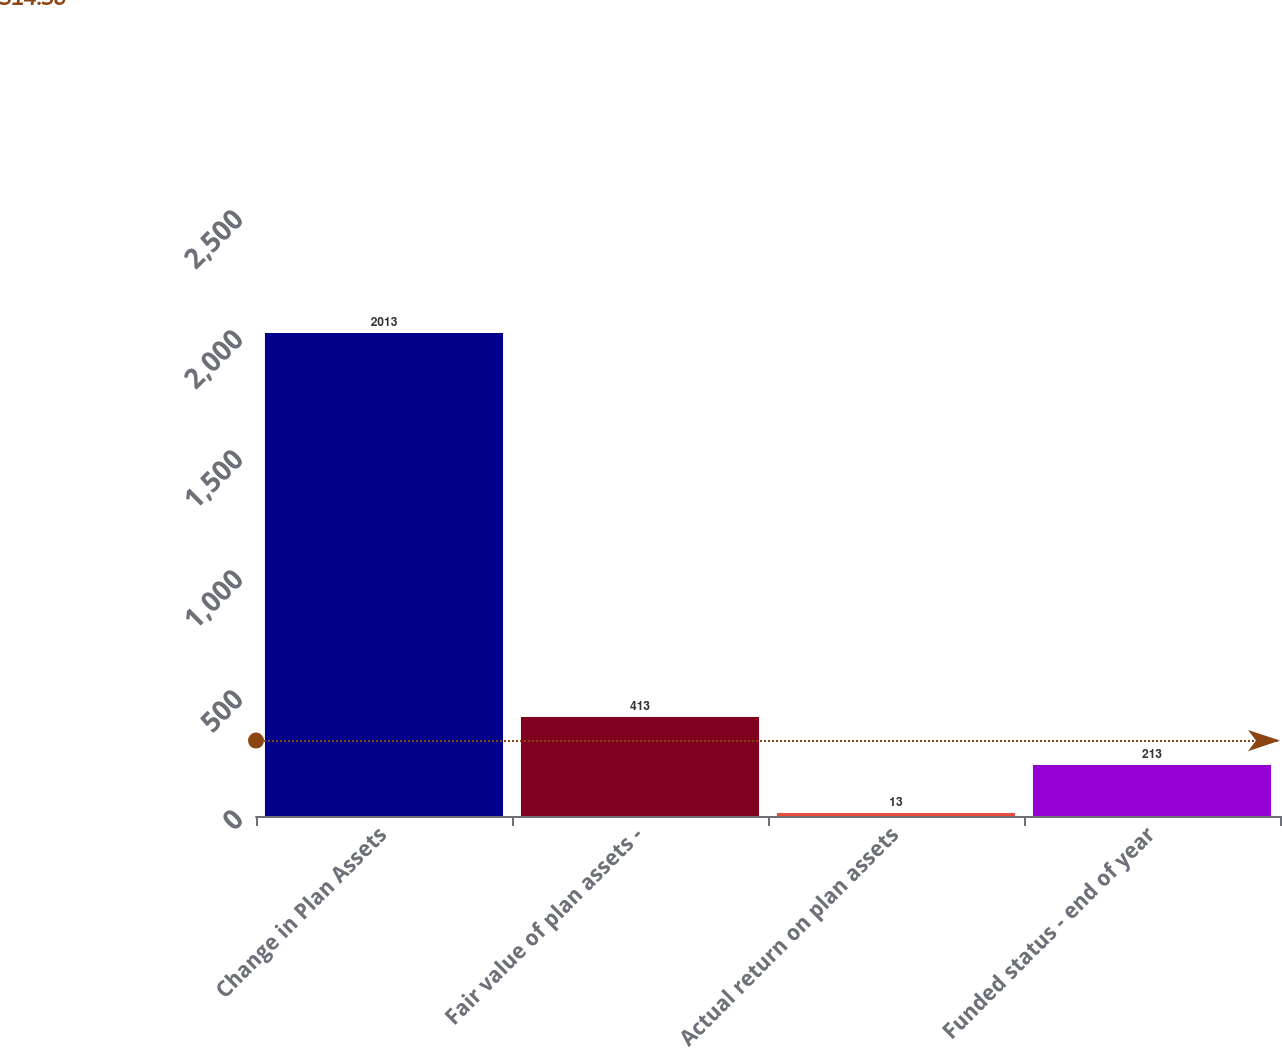Convert chart. <chart><loc_0><loc_0><loc_500><loc_500><bar_chart><fcel>Change in Plan Assets<fcel>Fair value of plan assets -<fcel>Actual return on plan assets<fcel>Funded status - end of year<nl><fcel>2013<fcel>413<fcel>13<fcel>213<nl></chart> 